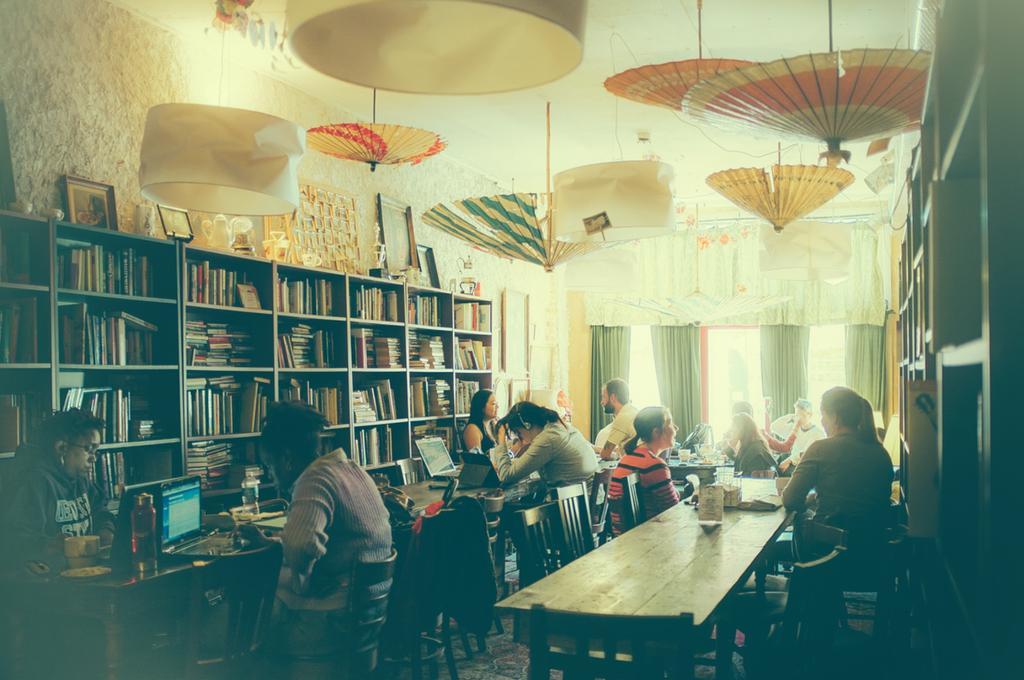Can you describe this image briefly? There are many persons sitting in the room. There are tables, chairs. On the table there are bottles, laptops and many other items. On the sides there are cupboards. Inside the cupboards there are books. On the cupboard there are photo frame. In the background there are windows and curtains. On the ceiling there are umbrellas and lamps are kept. 